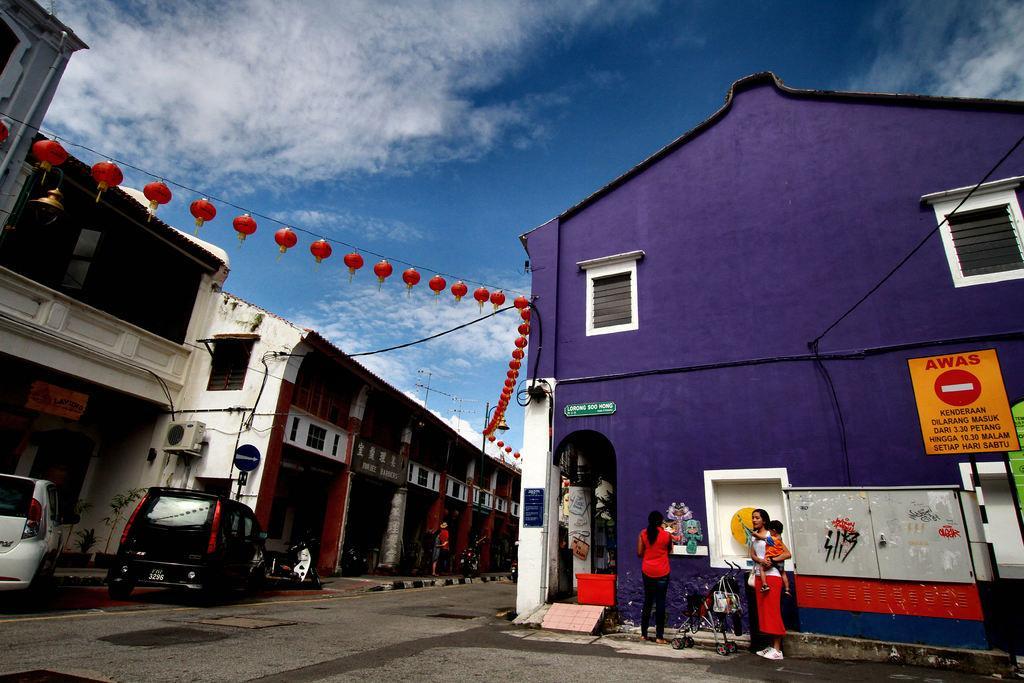Please provide a concise description of this image. This picture describes about group of people, few are standing and few are walking on the pathway, in this we can see few sign boards and vehicles on the road, and also we can see few buildings, lights and clouds. 